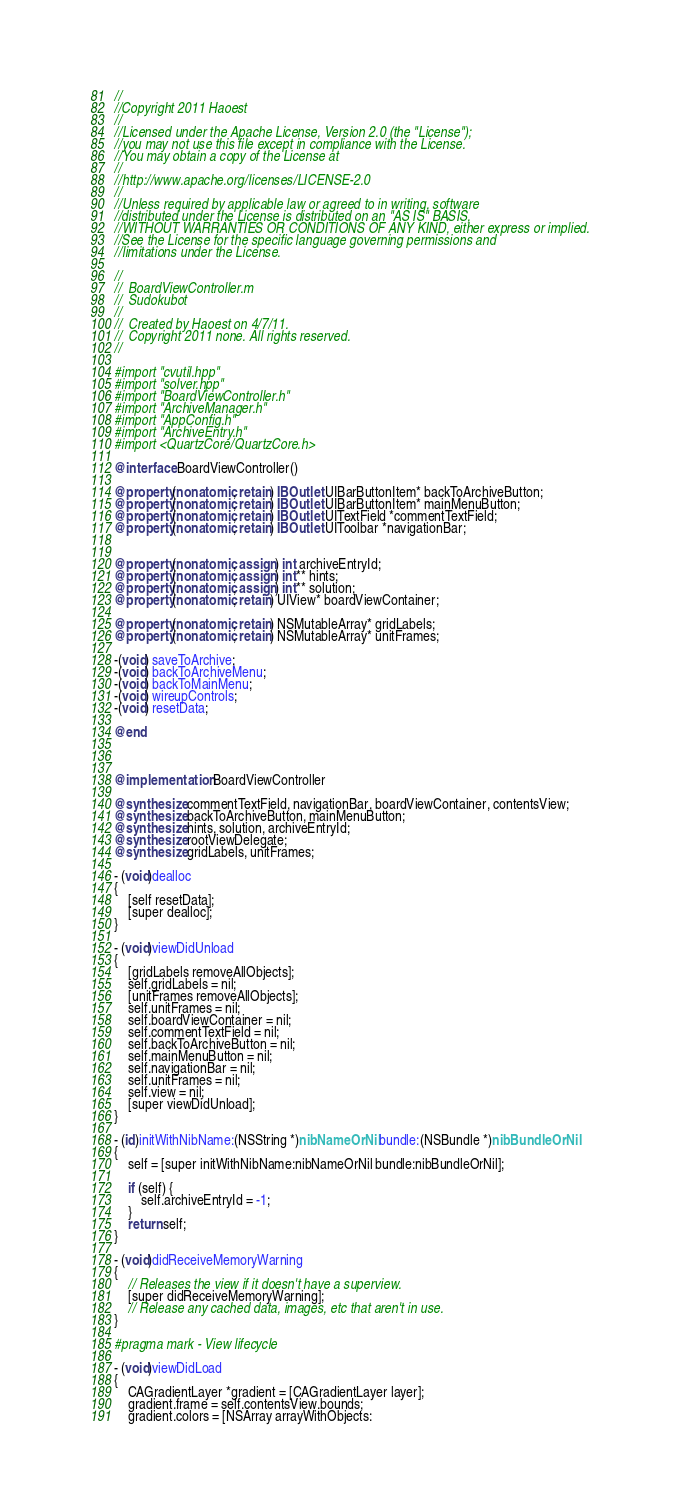<code> <loc_0><loc_0><loc_500><loc_500><_ObjectiveC_>//
//Copyright 2011 Haoest
//
//Licensed under the Apache License, Version 2.0 (the "License");
//you may not use this file except in compliance with the License.
//You may obtain a copy of the License at
//
//http://www.apache.org/licenses/LICENSE-2.0
//
//Unless required by applicable law or agreed to in writing, software
//distributed under the License is distributed on an "AS IS" BASIS,
//WITHOUT WARRANTIES OR CONDITIONS OF ANY KIND, either express or implied.
//See the License for the specific language governing permissions and
//limitations under the License.

//
//  BoardViewController.m
//  Sudokubot
//
//  Created by Haoest on 4/7/11.
//  Copyright 2011 none. All rights reserved.
//

#import "cvutil.hpp"
#import "solver.hpp"
#import "BoardViewController.h"
#import "ArchiveManager.h"
#import "AppConfig.h"
#import "ArchiveEntry.h"
#import <QuartzCore/QuartzCore.h>

@interface BoardViewController()

@property(nonatomic, retain) IBOutlet UIBarButtonItem* backToArchiveButton;
@property(nonatomic, retain) IBOutlet UIBarButtonItem* mainMenuButton;
@property(nonatomic, retain) IBOutlet UITextField *commentTextField;
@property(nonatomic, retain) IBOutlet UIToolbar *navigationBar;


@property(nonatomic, assign) int archiveEntryId;
@property(nonatomic, assign) int** hints;
@property(nonatomic, assign) int** solution;
@property(nonatomic, retain) UIView* boardViewContainer;

@property(nonatomic, retain) NSMutableArray* gridLabels;
@property(nonatomic, retain) NSMutableArray* unitFrames;

-(void) saveToArchive;
-(void) backToArchiveMenu;
-(void) backToMainMenu;
-(void) wireupControls;
-(void) resetData;

@end



@implementation BoardViewController

@synthesize commentTextField, navigationBar, boardViewContainer, contentsView;
@synthesize backToArchiveButton, mainMenuButton;
@synthesize hints, solution, archiveEntryId;
@synthesize rootViewDelegate;
@synthesize gridLabels, unitFrames;
 
- (void)dealloc
{
    [self resetData];
    [super dealloc];
}

- (void)viewDidUnload
{
    [gridLabels removeAllObjects];
    self.gridLabels = nil;
    [unitFrames removeAllObjects];
    self.unitFrames = nil;
    self.boardViewContainer = nil;
    self.commentTextField = nil;
    self.backToArchiveButton = nil;
    self.mainMenuButton = nil;
    self.navigationBar = nil;
    self.unitFrames = nil;
    self.view = nil;
    [super viewDidUnload];
}

- (id)initWithNibName:(NSString *)nibNameOrNil bundle:(NSBundle *)nibBundleOrNil
{
    self = [super initWithNibName:nibNameOrNil bundle:nibBundleOrNil];

    if (self) {
        self.archiveEntryId = -1;
    }
    return self;
}

- (void)didReceiveMemoryWarning
{
    // Releases the view if it doesn't have a superview.
    [super didReceiveMemoryWarning];
    // Release any cached data, images, etc that aren't in use.
}

#pragma mark - View lifecycle

- (void)viewDidLoad
{
    CAGradientLayer *gradient = [CAGradientLayer layer];
    gradient.frame = self.contentsView.bounds;
    gradient.colors = [NSArray arrayWithObjects: </code> 